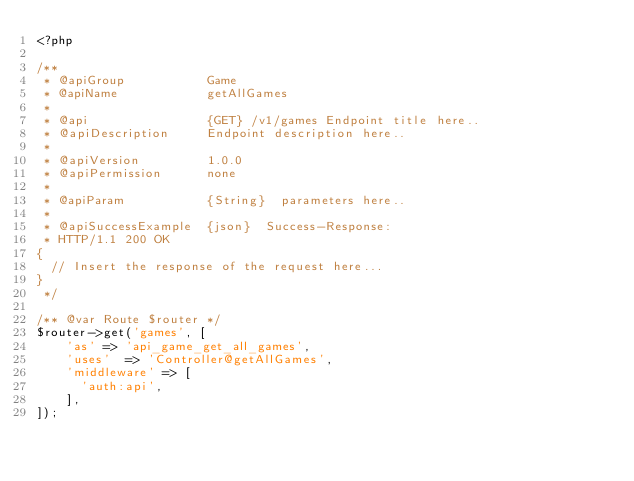Convert code to text. <code><loc_0><loc_0><loc_500><loc_500><_PHP_><?php

/**
 * @apiGroup           Game
 * @apiName            getAllGames
 *
 * @api                {GET} /v1/games Endpoint title here..
 * @apiDescription     Endpoint description here..
 *
 * @apiVersion         1.0.0
 * @apiPermission      none
 *
 * @apiParam           {String}  parameters here..
 *
 * @apiSuccessExample  {json}  Success-Response:
 * HTTP/1.1 200 OK
{
  // Insert the response of the request here...
}
 */

/** @var Route $router */
$router->get('games', [
    'as' => 'api_game_get_all_games',
    'uses'  => 'Controller@getAllGames',
    'middleware' => [
      'auth:api',
    ],
]);
</code> 